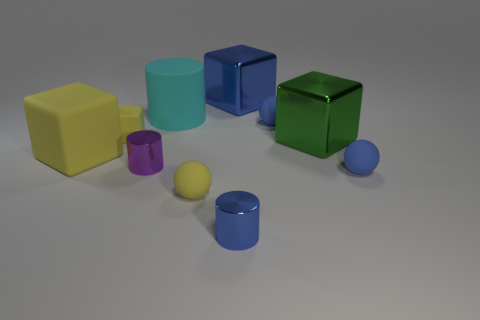Is there another matte block of the same color as the big rubber cube?
Your response must be concise. Yes. There is a rubber block that is in front of the big green shiny object; is it the same color as the tiny rubber block?
Make the answer very short. Yes. How many other things are the same color as the small rubber cube?
Make the answer very short. 2. What number of gray things are either tiny shiny cylinders or tiny rubber blocks?
Provide a succinct answer. 0. How many metallic things are either blue objects or large yellow cubes?
Give a very brief answer. 2. Are there any tiny objects?
Ensure brevity in your answer.  Yes. Does the small blue shiny thing have the same shape as the large green thing?
Offer a terse response. No. How many small rubber balls are in front of the metallic object to the right of the tiny sphere that is behind the large yellow matte block?
Keep it short and to the point. 2. What is the material of the cube that is both to the right of the big yellow thing and on the left side of the purple metal cylinder?
Your response must be concise. Rubber. The small object that is both on the right side of the yellow ball and behind the big yellow object is what color?
Provide a succinct answer. Blue. 